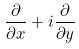<formula> <loc_0><loc_0><loc_500><loc_500>\frac { \partial } { \partial x } + i \frac { \partial } { \partial y }</formula> 